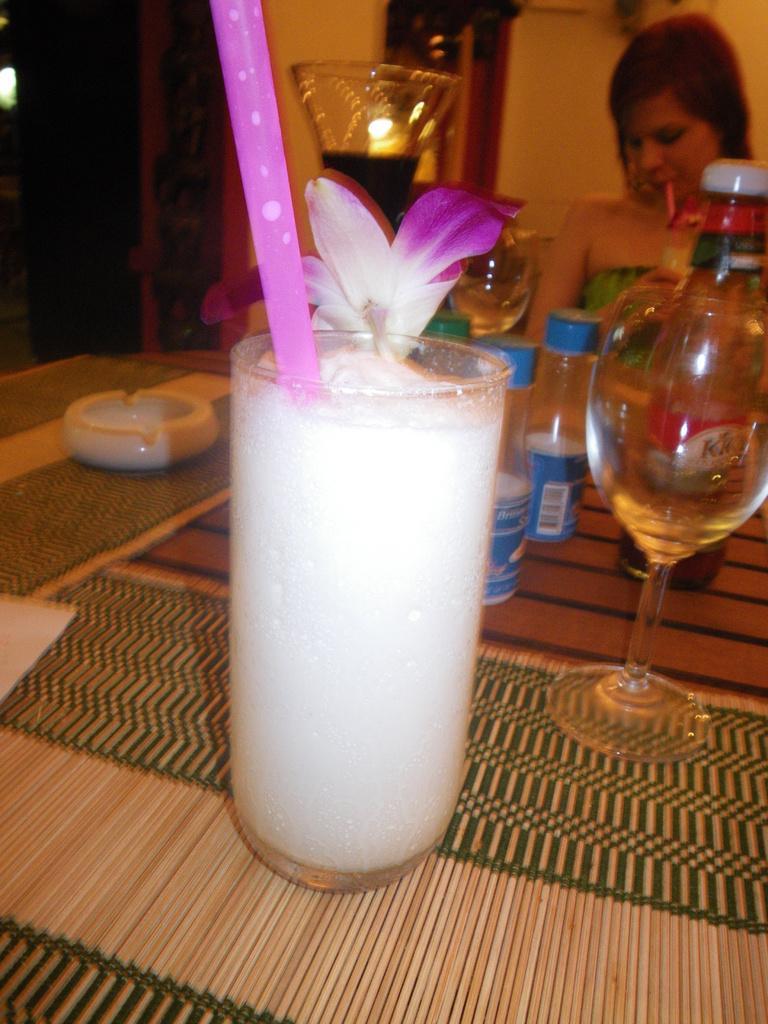Can you describe this image briefly? There is a table. On the table there is a glass with juice, straw and flower. Also there are bottles, another glasses and mats on the table. There is a lady on the backside. 